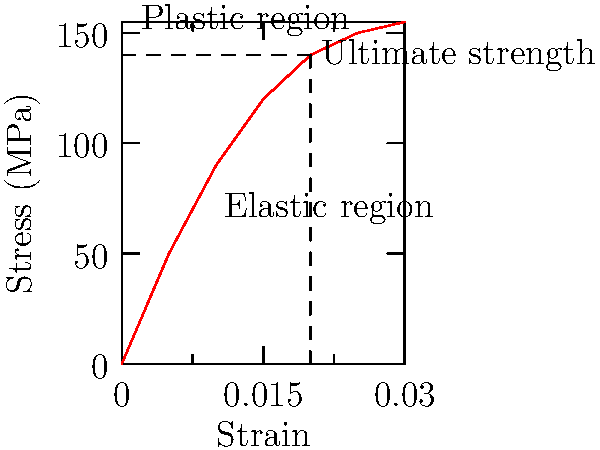As a program officer evaluating a biomechanics research proposal, you encounter a stress-strain curve for bone tissue. At what approximate strain value does the bone tissue reach its ultimate strength, and what implications does this have for funding decisions related to bone health research? To answer this question, we need to analyze the stress-strain curve provided and understand its implications for bone tissue behavior:

1. Identify the ultimate strength: The ultimate strength is the maximum stress that a material can withstand before failure. On the graph, this is represented by the highest point on the curve.

2. Locate the strain value: Draw a vertical line from the highest point on the curve to the x-axis (strain axis). This line intersects the x-axis at the strain value corresponding to the ultimate strength.

3. Read the strain value: The dashed lines on the graph indicate that the ultimate strength occurs at a strain of approximately 0.02 or 2%.

4. Interpret the results: 
   a) The elastic region (initial linear portion) represents reversible deformation.
   b) The plastic region (curved portion after the elastic region) represents permanent deformation.
   c) The ultimate strength point marks the transition from the ability to bear load to failure.

5. Implications for funding decisions:
   a) Research focusing on maintaining bone elasticity within the 0-2% strain range could be prioritized.
   b) Projects aimed at increasing the ultimate strength of bone tissue may be valuable for preventing fractures.
   c) Studies on bone remodeling and repair after reaching the plastic region could be important for recovery research.
   d) Funding could be directed towards developing treatments or interventions that aim to shift the curve to the right, increasing the strain tolerance of bone tissue.

As a program officer, understanding this stress-strain relationship is crucial for evaluating the potential impact and relevance of proposed biomechanics research projects related to bone health.
Answer: Strain ≈ 0.02 (2%); Prioritize research on bone elasticity, strength enhancement, and post-plastic region recovery. 